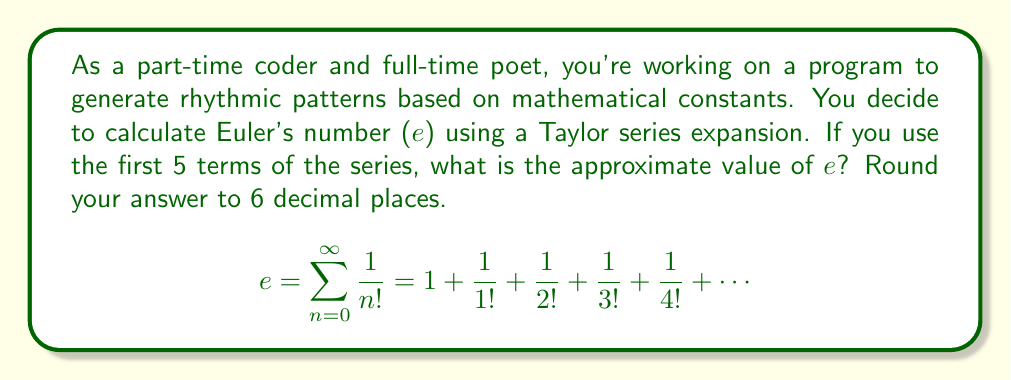Teach me how to tackle this problem. To calculate e using the Taylor series expansion with 5 terms:

1. Write out the first 5 terms of the series:
   $$e \approx 1 + \frac{1}{1!} + \frac{1}{2!} + \frac{1}{3!} + \frac{1}{4!}$$

2. Calculate each term:
   - $1 = 1$
   - $\frac{1}{1!} = 1$
   - $\frac{1}{2!} = \frac{1}{2} = 0.5$
   - $\frac{1}{3!} = \frac{1}{6} \approx 0.166667$
   - $\frac{1}{4!} = \frac{1}{24} \approx 0.041667$

3. Sum the terms:
   $$e \approx 1 + 1 + 0.5 + 0.166667 + 0.041667$$

4. Calculate the sum:
   $$e \approx 2.708334$$

5. Round to 6 decimal places:
   $$e \approx 2.708333$$
Answer: 2.708333 